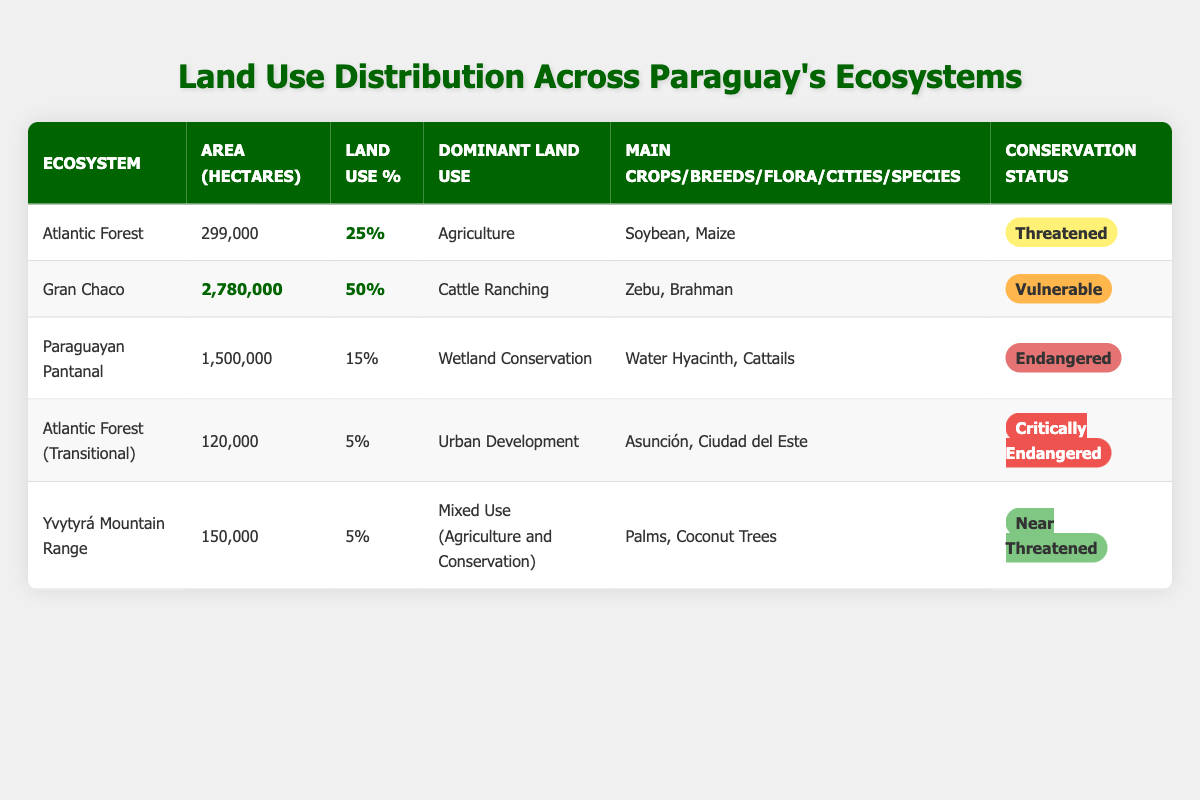What is the dominant land use in the Atlantic Forest ecosystem? The table shows the dominant land use for the Atlantic Forest ecosystem as "Agriculture." This is directly mentioned in the row corresponding to the Atlantic Forest.
Answer: Agriculture Which ecosystem has the largest area in hectares? By comparing the area in hectares for each ecosystem, Gran Chaco has the largest area at 2,780,000 hectares, as highlighted in the table.
Answer: Gran Chaco What percentage of land use is attributed to the Paraguayan Pantanal? The table indicates that the percentage of land use for the Paraguayan Pantanal is 15%, found in the row for this ecosystem.
Answer: 15% How many hectares are used for urban development in the Atlantic Forest (Transitional)? The area listed for urban development in the Atlantic Forest (Transitional) is 120,000 hectares. This is a direct retrieval from the table.
Answer: 120,000 Which ecosystem has the conservation status labeled as "Critically Endangered"? The conservation status for the Atlantic Forest (Transitional) is labeled as "Critically Endangered," as noted in the table.
Answer: Atlantic Forest (Transitional) What are the main crops grown in the Atlantic Forest ecosystem? The table specifies that the main crops in the Atlantic Forest ecosystem are "Soybean" and "Maize," which can be found in the corresponding row for this ecosystem.
Answer: Soybean, Maize Calculate the total area in hectares for the Atlantic Forest and Yvytyrá Mountain Range combined. The area for the Atlantic Forest is 299,000 hectares, and for the Yvytyrá Mountain Range, it is 150,000 hectares. Adding these two areas gives us 299,000 + 150,000 = 449,000 hectares.
Answer: 449,000 How many ecosystems have 5% or less of their land used according to the table? The ecosystems with 5% or less are Atlantic Forest (Transitional) and Yvytyrá Mountain Range, each with 5%. Therefore, there are 2 ecosystems fitting this criterion.
Answer: 2 Are there any ecosystems that fall under the "Endangered" conservation status? The Paraguayan Pantanal ecosystem is marked as "Endangered" according to the conservation status in the table. Thus, the answer is yes.
Answer: Yes What percentage of the total land use does the Gran Chaco represent compared to the total of the other ecosystems? The Gran Chaco has a land use percentage of 50%. Adding the other ecosystems' percentages: 25 (Atlantic Forest) + 15 (Paraguayan Pantanal) + 5 (Atlantic Forest Transitional) + 5 (Yvytyrá) = 50%. So, Gran Chaco represents half of the total land use.
Answer: 50% 